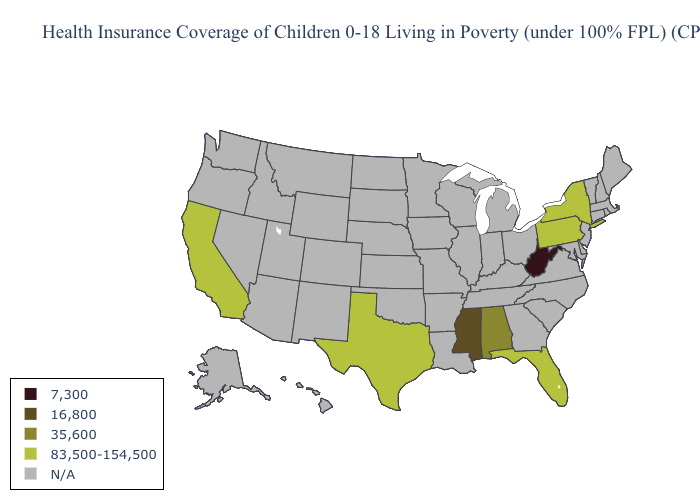Name the states that have a value in the range N/A?
Quick response, please. Alaska, Arizona, Arkansas, Colorado, Connecticut, Delaware, Georgia, Hawaii, Idaho, Illinois, Indiana, Iowa, Kansas, Kentucky, Louisiana, Maine, Maryland, Massachusetts, Michigan, Minnesota, Missouri, Montana, Nebraska, Nevada, New Hampshire, New Jersey, New Mexico, North Carolina, North Dakota, Ohio, Oklahoma, Oregon, Rhode Island, South Carolina, South Dakota, Tennessee, Utah, Vermont, Virginia, Washington, Wisconsin, Wyoming. Does Pennsylvania have the highest value in the USA?
Concise answer only. Yes. What is the highest value in the Northeast ?
Answer briefly. 83,500-154,500. What is the value of Michigan?
Answer briefly. N/A. Name the states that have a value in the range 35,600?
Short answer required. Alabama. Does California have the lowest value in the USA?
Write a very short answer. No. What is the value of Nevada?
Keep it brief. N/A. Name the states that have a value in the range 83,500-154,500?
Write a very short answer. California, Florida, New York, Pennsylvania, Texas. Name the states that have a value in the range N/A?
Give a very brief answer. Alaska, Arizona, Arkansas, Colorado, Connecticut, Delaware, Georgia, Hawaii, Idaho, Illinois, Indiana, Iowa, Kansas, Kentucky, Louisiana, Maine, Maryland, Massachusetts, Michigan, Minnesota, Missouri, Montana, Nebraska, Nevada, New Hampshire, New Jersey, New Mexico, North Carolina, North Dakota, Ohio, Oklahoma, Oregon, Rhode Island, South Carolina, South Dakota, Tennessee, Utah, Vermont, Virginia, Washington, Wisconsin, Wyoming. What is the value of Oregon?
Keep it brief. N/A. Which states hav the highest value in the Northeast?
Give a very brief answer. New York, Pennsylvania. Name the states that have a value in the range 16,800?
Answer briefly. Mississippi. What is the value of Delaware?
Be succinct. N/A. Name the states that have a value in the range 7,300?
Answer briefly. West Virginia. 